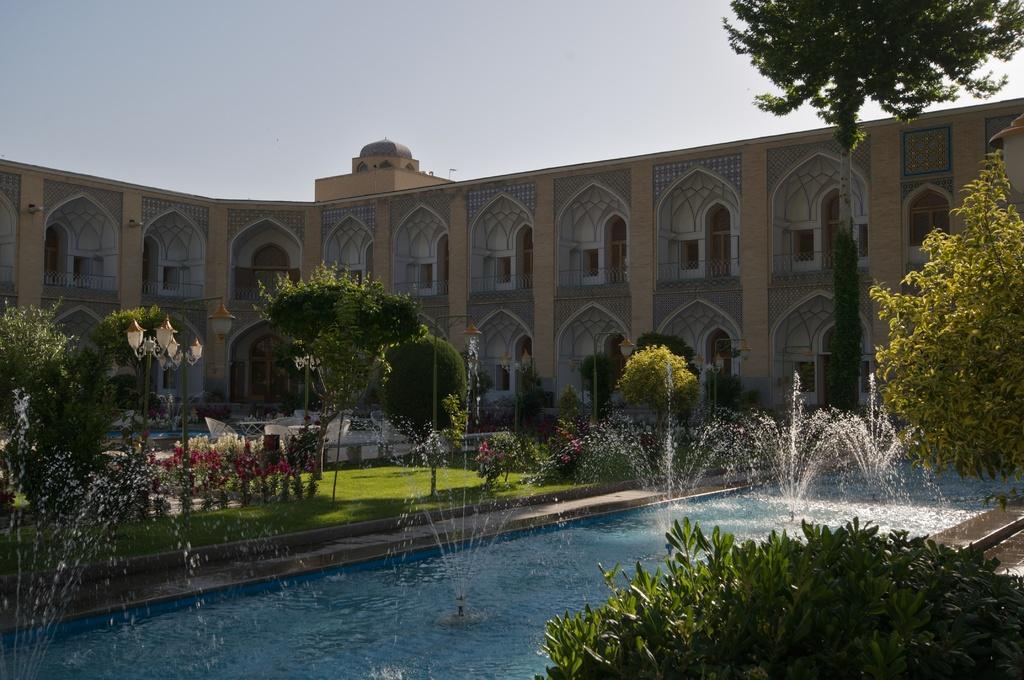Can you describe this image briefly? In this image there is a water fountain, beside the water fountain there is grass on the surface and there are trees, in the background of the image there is a building and a lamp post. 